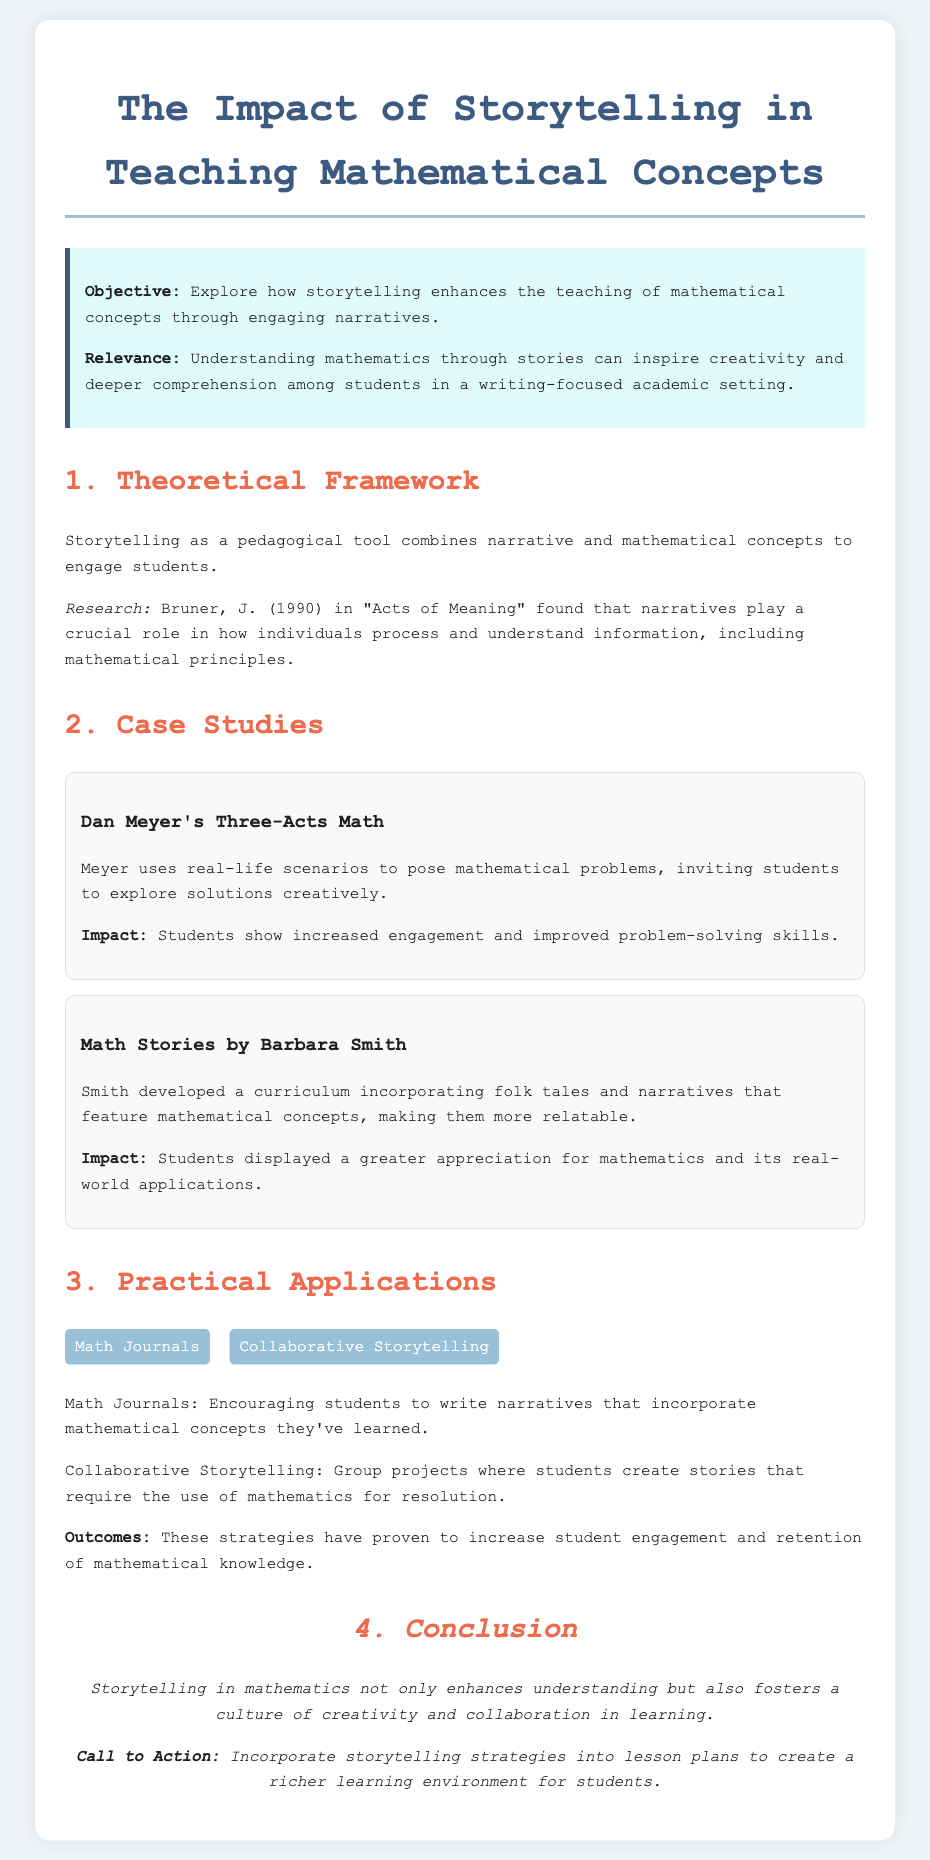What is the objective of the document? The objective outlines the intention to explore the enhancement of teaching mathematical concepts through storytelling.
Answer: Explore how storytelling enhances the teaching of mathematical concepts through engaging narratives Who conducted research mentioned in the theoretical framework? The document references J. Bruner's 1990 work in explaining the role of narratives in understanding information.
Answer: J. Bruner What are the names of the case studies mentioned? The document lists two specific case studies that explore storytelling in mathematics education.
Answer: Dan Meyer's Three-Acts Math, Math Stories by Barbara Smith What is one of the practical applications mentioned? The document highlights strategies used to implement storytelling in math education, aiming to boost engagement.
Answer: Math Journals What is the call to action in the conclusion? The conclusion encourages a specific strategy aimed at enriching the learning environment through storytelling.
Answer: Incorporate storytelling strategies into lesson plans 